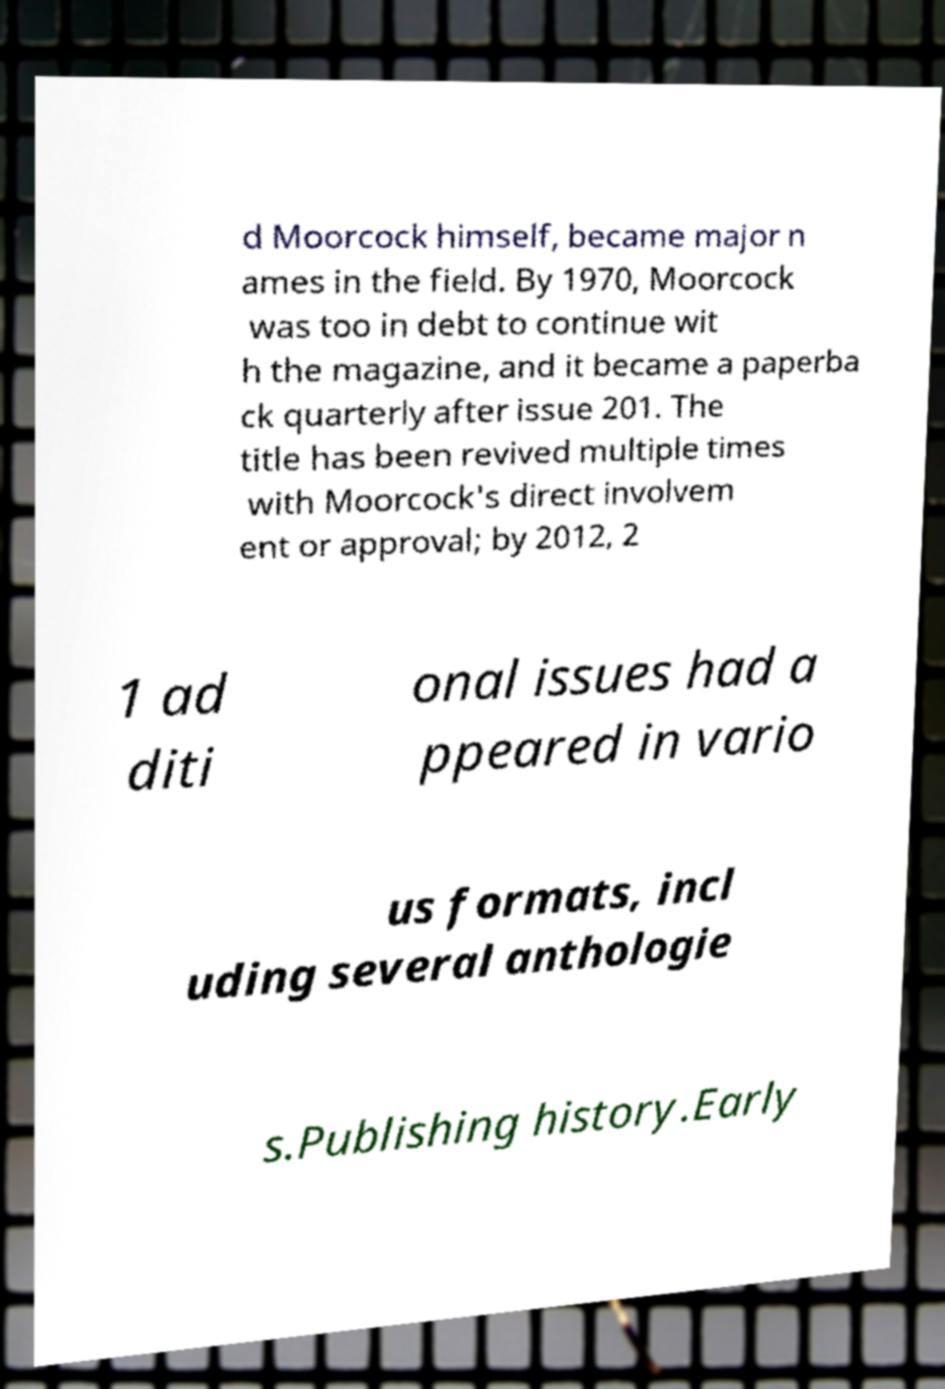Please identify and transcribe the text found in this image. d Moorcock himself, became major n ames in the field. By 1970, Moorcock was too in debt to continue wit h the magazine, and it became a paperba ck quarterly after issue 201. The title has been revived multiple times with Moorcock's direct involvem ent or approval; by 2012, 2 1 ad diti onal issues had a ppeared in vario us formats, incl uding several anthologie s.Publishing history.Early 